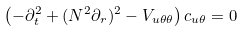<formula> <loc_0><loc_0><loc_500><loc_500>\left ( - { \partial } _ { t } ^ { 2 } + ( N ^ { 2 } { \partial } _ { r } ) ^ { 2 } - V _ { u \theta \theta } \right ) c _ { u \theta } = 0</formula> 